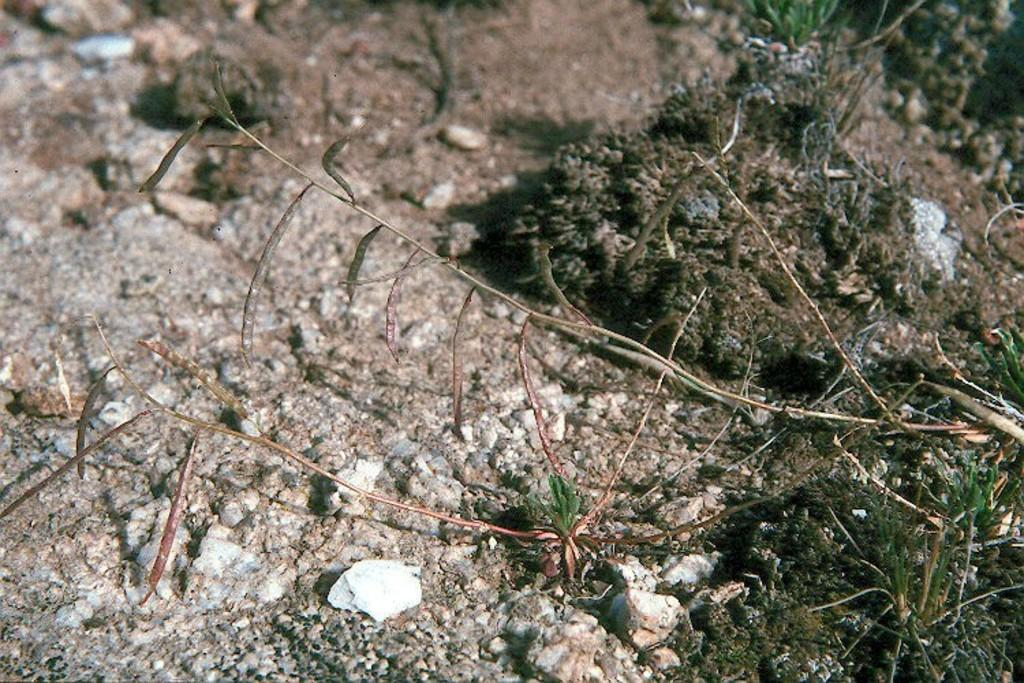What type of terrain is visible in the image? There is grass, stones, and sand on the ground in the image. Can you describe the different elements present in the terrain? The terrain consists of grass, stones, and sand. How many kites can be seen flying in the image? There are no kites visible in the image. What type of sponge is being used to clean the stones in the image? There is no sponge present in the image, and the stones are not being cleaned. 